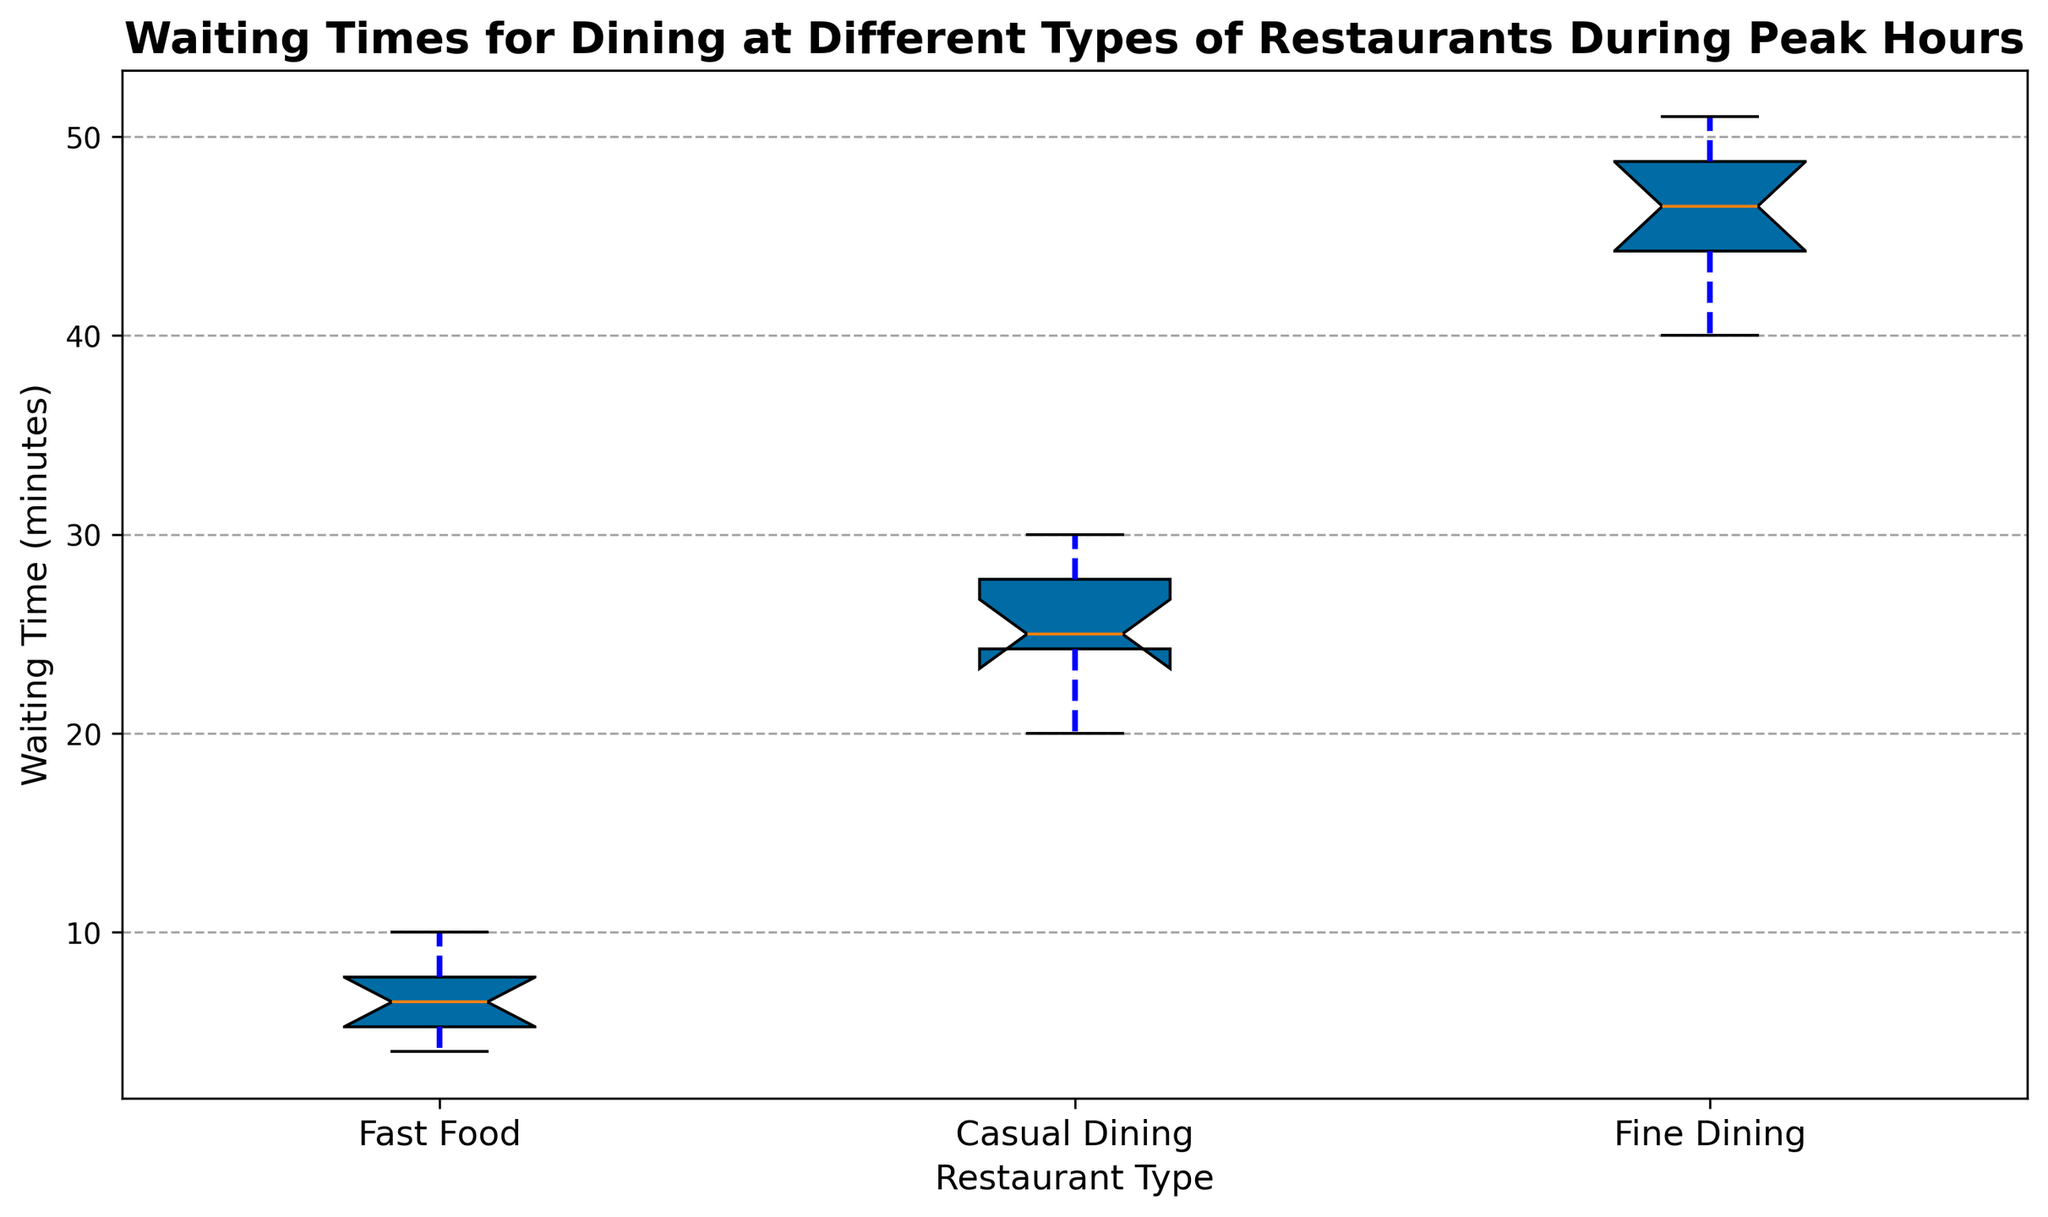what is the median waiting time for Casual Dining? Identify the middle value in the sorted list of waiting times for Casual Dining. The sorted list is [20, 22, 24, 25, 25, 25, 27, 28, 30, 30], so the median is the average of the 5th and 6th values: (25 + 25)/2 = 25
Answer: 25 Which restaurant type has the widest range of waiting times? Calculate the range as the difference between the maximum and minimum waiting times for each restaurant type. Fine Dining has the widest range, with a maximum of 51 and a minimum of 40, giving a range of 11 minutes
Answer: Fine Dining What is the interquartile range (IQR) of waiting times for Fast Food restaurants? The IQR is calculated as the difference between the third quartile (Q3) and the first quartile (Q1). From the box plot, Q1 is 5 minutes and Q3 is 9 minutes. So, IQR = 9 - 5 = 4
Answer: 4 Which restaurant type has the highest median waiting time? The median waiting time is indicated by the line inside the box of each box plot. Fine Dining has the highest median waiting time, which is 46 minutes
Answer: Fine Dining How does the mean waiting time for Fast Food compare to the median waiting time for Fine Dining? The mean waiting time for Fast Food, indicated by the dashed line, lies around 6.5 minutes. The median waiting time for Fine Dining is 46 minutes. Thus, the median for Fine Dining is much higher than the mean for Fast Food
Answer: Fine Dining is much higher Which type of restaurant shows more variability in waiting times, Fast Food or Casual Dining? Variability can be observed by the length of the whiskers and the spread of the box. Casual Dining shows more variability due to a broader box and longer whiskers compared to Fast Food
Answer: Casual Dining What is the minimum waiting time observed for Fine Dining restaurants? The minimum value is indicated at the bottom of the whisker for Fine Dining, which is 40 minutes
Answer: 40 Which restaurant type has the most outliers? Outliers are indicated by the points outside the whiskers on the box plot. Fast Food has the most outliers, shown in red circles, above the box plot
Answer: Fast Food 